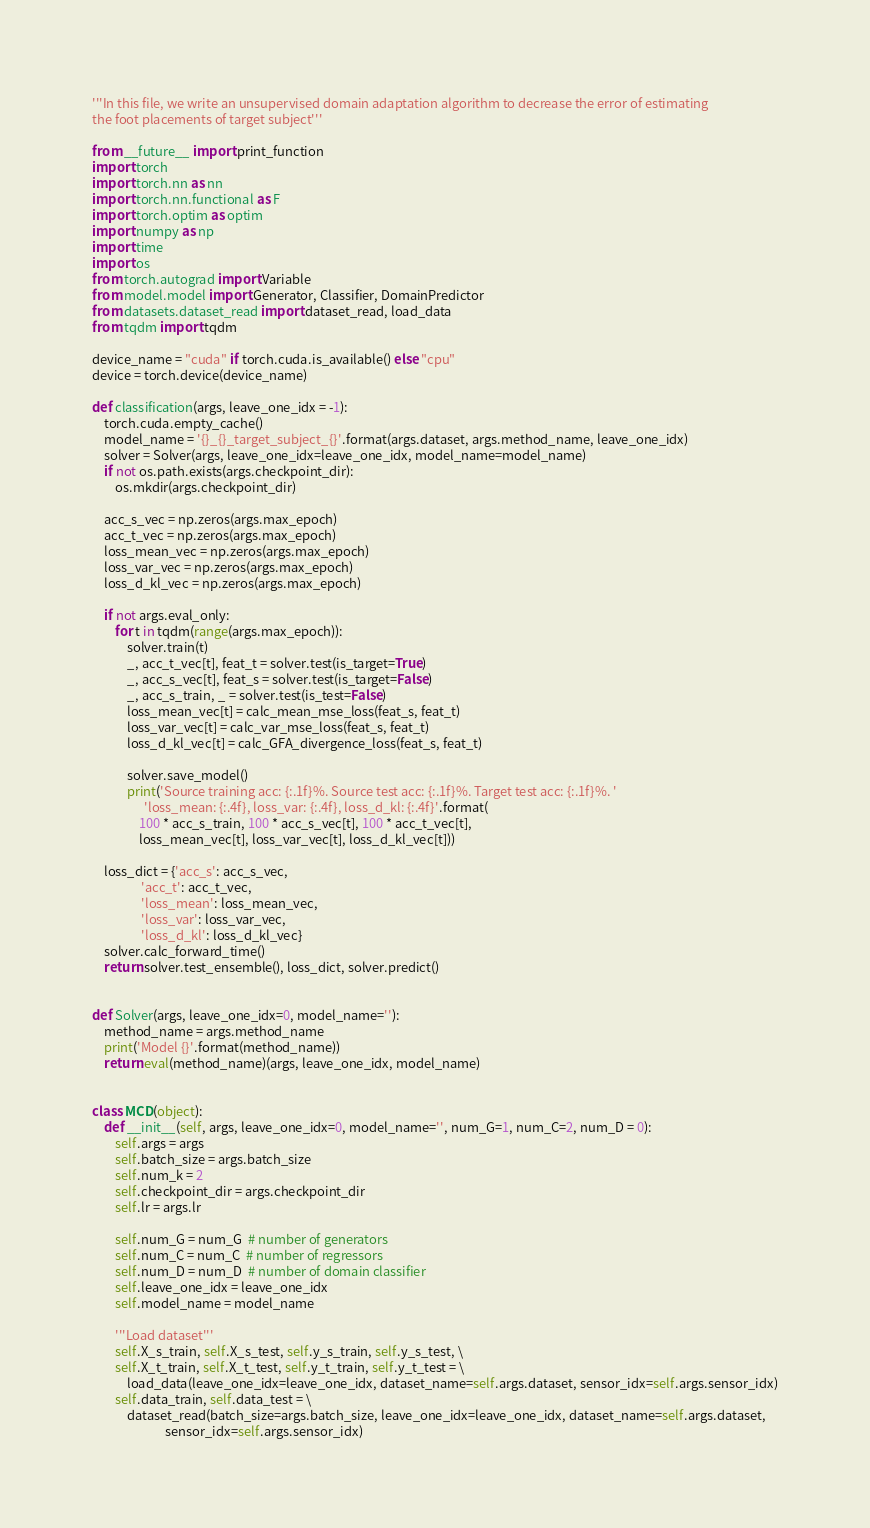Convert code to text. <code><loc_0><loc_0><loc_500><loc_500><_Python_>'''In this file, we write an unsupervised domain adaptation algorithm to decrease the error of estimating
the foot placements of target subject'''

from __future__ import print_function
import torch
import torch.nn as nn
import torch.nn.functional as F
import torch.optim as optim
import numpy as np
import time
import os
from torch.autograd import Variable
from model.model import Generator, Classifier, DomainPredictor
from datasets.dataset_read import dataset_read, load_data
from tqdm import tqdm

device_name = "cuda" if torch.cuda.is_available() else "cpu"
device = torch.device(device_name)

def classification(args, leave_one_idx = -1):
    torch.cuda.empty_cache()
    model_name = '{}_{}_target_subject_{}'.format(args.dataset, args.method_name, leave_one_idx)
    solver = Solver(args, leave_one_idx=leave_one_idx, model_name=model_name)
    if not os.path.exists(args.checkpoint_dir):
        os.mkdir(args.checkpoint_dir)

    acc_s_vec = np.zeros(args.max_epoch)
    acc_t_vec = np.zeros(args.max_epoch)
    loss_mean_vec = np.zeros(args.max_epoch)
    loss_var_vec = np.zeros(args.max_epoch)
    loss_d_kl_vec = np.zeros(args.max_epoch)

    if not args.eval_only:
        for t in tqdm(range(args.max_epoch)):
            solver.train(t)
            _, acc_t_vec[t], feat_t = solver.test(is_target=True)
            _, acc_s_vec[t], feat_s = solver.test(is_target=False)
            _, acc_s_train, _ = solver.test(is_test=False)
            loss_mean_vec[t] = calc_mean_mse_loss(feat_s, feat_t)
            loss_var_vec[t] = calc_var_mse_loss(feat_s, feat_t)
            loss_d_kl_vec[t] = calc_GFA_divergence_loss(feat_s, feat_t)

            solver.save_model()
            print('Source training acc: {:.1f}%. Source test acc: {:.1f}%. Target test acc: {:.1f}%. '
                  'loss_mean: {:.4f}, loss_var: {:.4f}, loss_d_kl: {:.4f}'.format(
                100 * acc_s_train, 100 * acc_s_vec[t], 100 * acc_t_vec[t],
                loss_mean_vec[t], loss_var_vec[t], loss_d_kl_vec[t]))

    loss_dict = {'acc_s': acc_s_vec,
                 'acc_t': acc_t_vec,
                 'loss_mean': loss_mean_vec,
                 'loss_var': loss_var_vec,
                 'loss_d_kl': loss_d_kl_vec}
    solver.calc_forward_time()
    return solver.test_ensemble(), loss_dict, solver.predict()


def Solver(args, leave_one_idx=0, model_name=''):
    method_name = args.method_name
    print('Model {}'.format(method_name))
    return eval(method_name)(args, leave_one_idx, model_name)


class MCD(object):
    def __init__(self, args, leave_one_idx=0, model_name='', num_G=1, num_C=2, num_D = 0):
        self.args = args
        self.batch_size = args.batch_size
        self.num_k = 2
        self.checkpoint_dir = args.checkpoint_dir
        self.lr = args.lr

        self.num_G = num_G  # number of generators
        self.num_C = num_C  # number of regressors
        self.num_D = num_D  # number of domain classifier
        self.leave_one_idx = leave_one_idx
        self.model_name = model_name

        '''Load dataset'''
        self.X_s_train, self.X_s_test, self.y_s_train, self.y_s_test, \
        self.X_t_train, self.X_t_test, self.y_t_train, self.y_t_test = \
            load_data(leave_one_idx=leave_one_idx, dataset_name=self.args.dataset, sensor_idx=self.args.sensor_idx)
        self.data_train, self.data_test = \
            dataset_read(batch_size=args.batch_size, leave_one_idx=leave_one_idx, dataset_name=self.args.dataset,
                         sensor_idx=self.args.sensor_idx)
</code> 